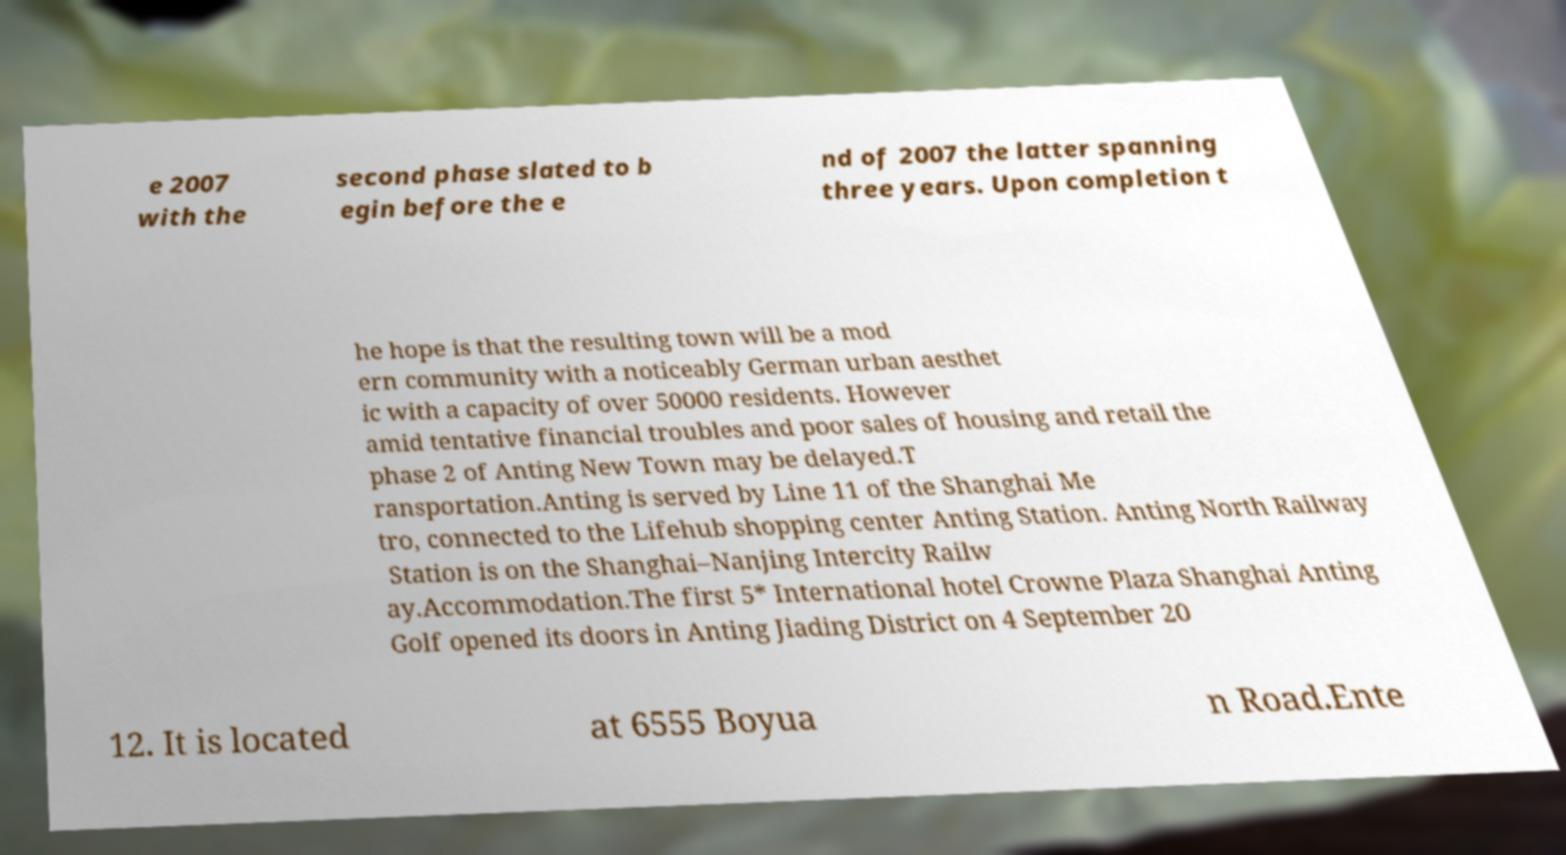For documentation purposes, I need the text within this image transcribed. Could you provide that? e 2007 with the second phase slated to b egin before the e nd of 2007 the latter spanning three years. Upon completion t he hope is that the resulting town will be a mod ern community with a noticeably German urban aesthet ic with a capacity of over 50000 residents. However amid tentative financial troubles and poor sales of housing and retail the phase 2 of Anting New Town may be delayed.T ransportation.Anting is served by Line 11 of the Shanghai Me tro, connected to the Lifehub shopping center Anting Station. Anting North Railway Station is on the Shanghai–Nanjing Intercity Railw ay.Accommodation.The first 5* International hotel Crowne Plaza Shanghai Anting Golf opened its doors in Anting Jiading District on 4 September 20 12. It is located at 6555 Boyua n Road.Ente 